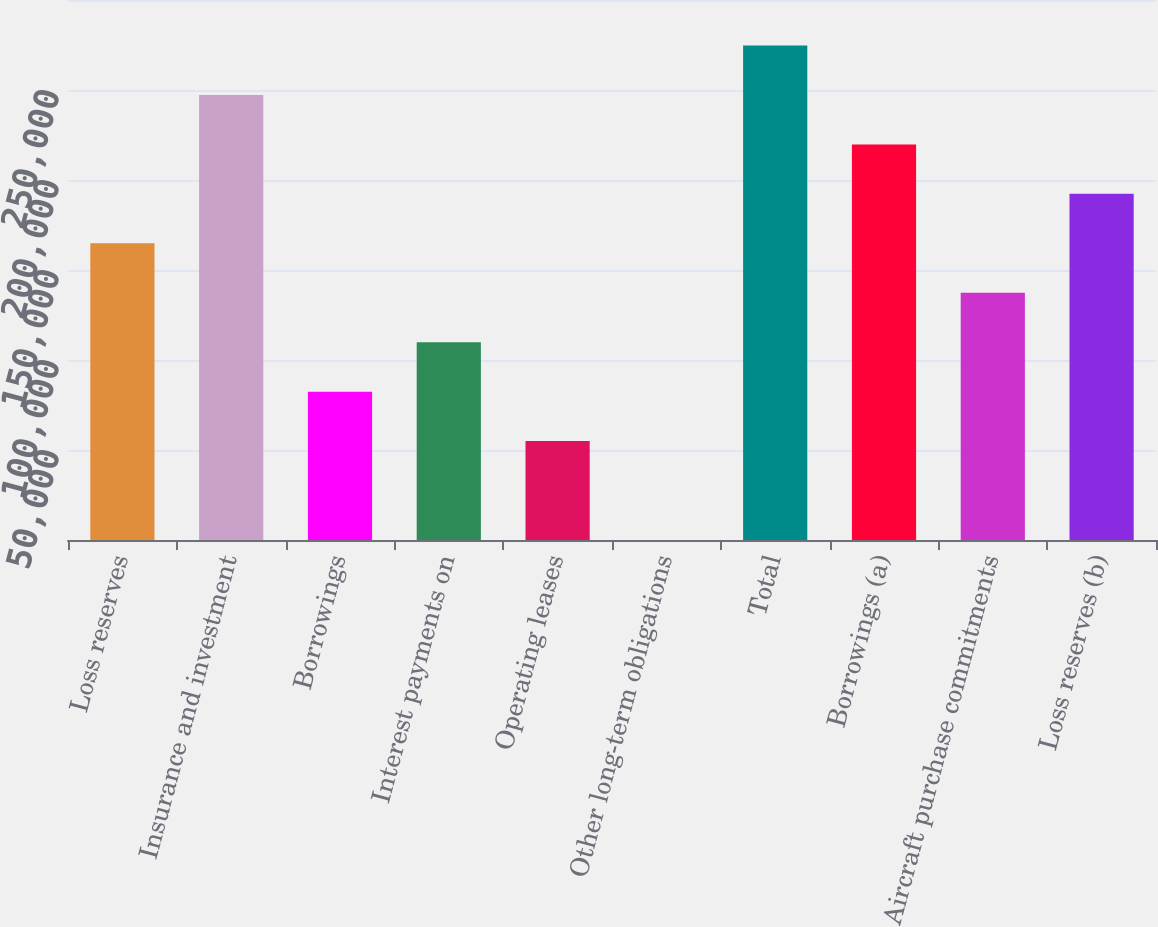Convert chart to OTSL. <chart><loc_0><loc_0><loc_500><loc_500><bar_chart><fcel>Loss reserves<fcel>Insurance and investment<fcel>Borrowings<fcel>Interest payments on<fcel>Operating leases<fcel>Other long-term obligations<fcel>Total<fcel>Borrowings (a)<fcel>Aircraft purchase commitments<fcel>Loss reserves (b)<nl><fcel>164830<fcel>247241<fcel>82417.8<fcel>109888<fcel>54947.2<fcel>6<fcel>274712<fcel>219771<fcel>137359<fcel>192300<nl></chart> 